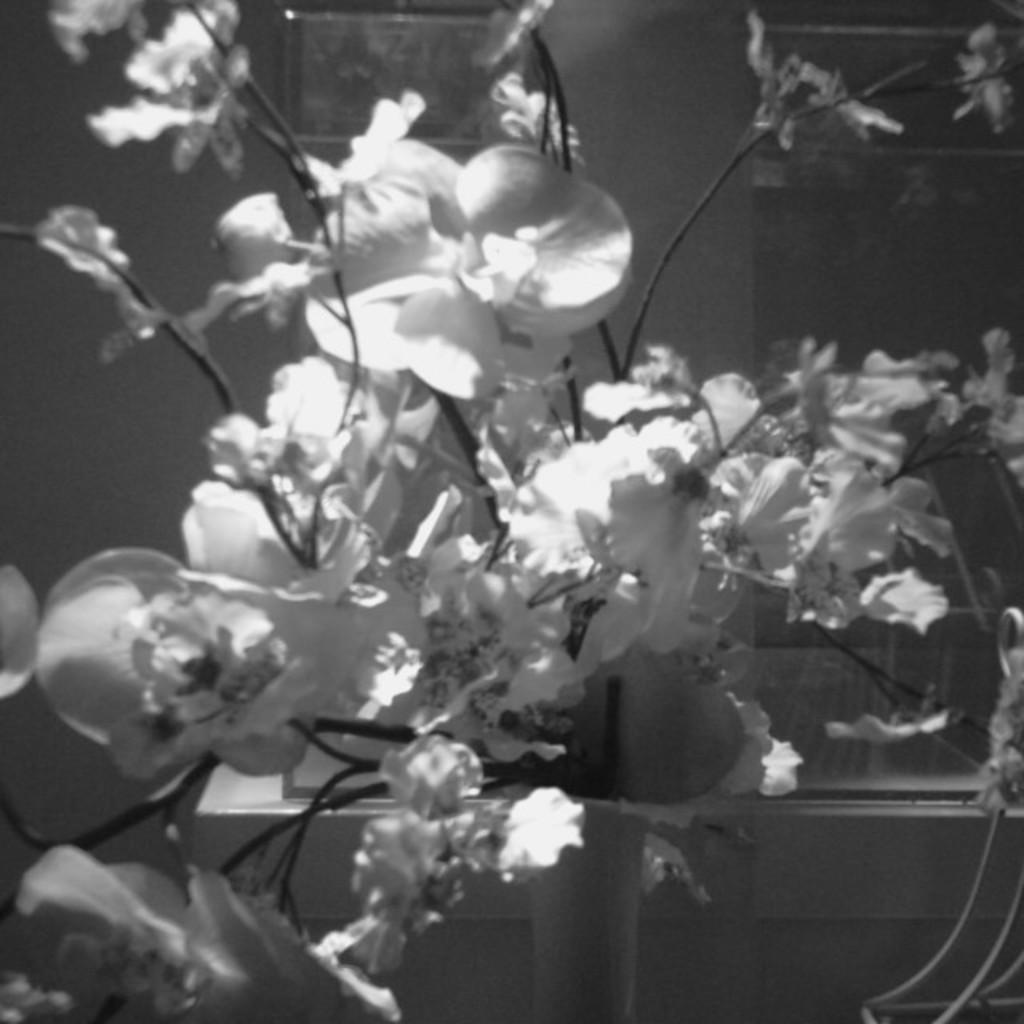What is the color scheme of the image? The image is black and white. What can be seen in the middle of the image? There are small flowers in the middle of the image. What type of toy is visible in the image? There is no toy present in the image; it features small flowers in a black and white color scheme. What kind of bread can be seen in the image? There is no bread or loaf present in the image; it only contains small flowers. 